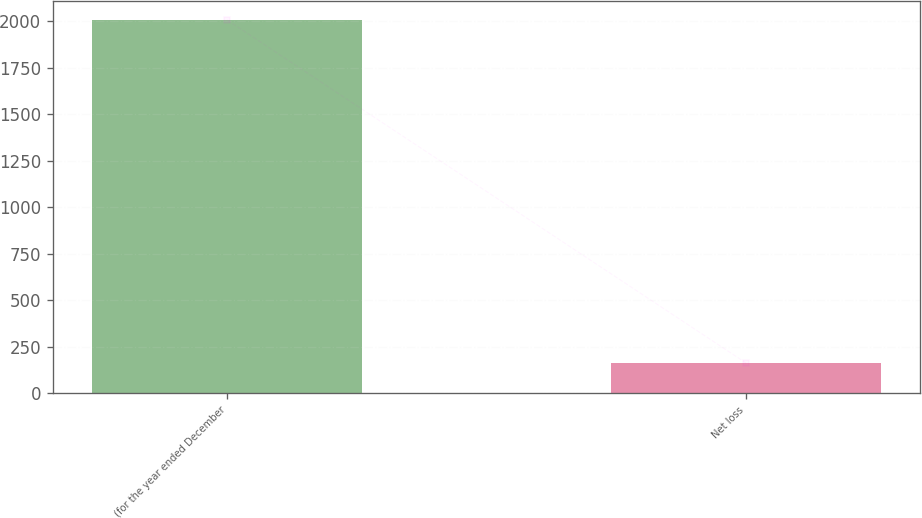Convert chart. <chart><loc_0><loc_0><loc_500><loc_500><bar_chart><fcel>(for the year ended December<fcel>Net loss<nl><fcel>2006<fcel>163<nl></chart> 